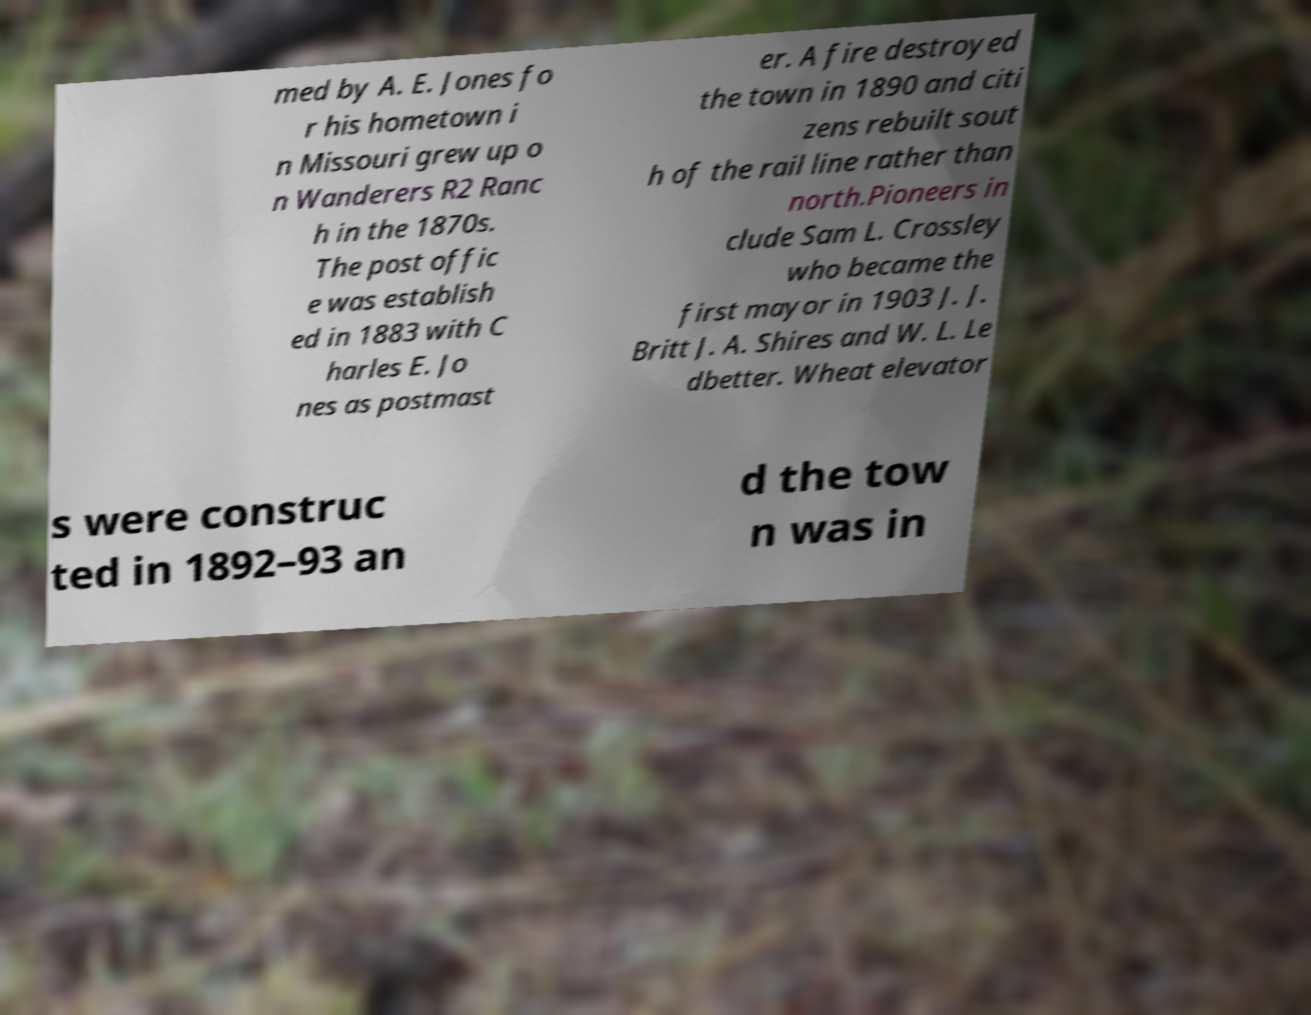There's text embedded in this image that I need extracted. Can you transcribe it verbatim? med by A. E. Jones fo r his hometown i n Missouri grew up o n Wanderers R2 Ranc h in the 1870s. The post offic e was establish ed in 1883 with C harles E. Jo nes as postmast er. A fire destroyed the town in 1890 and citi zens rebuilt sout h of the rail line rather than north.Pioneers in clude Sam L. Crossley who became the first mayor in 1903 J. J. Britt J. A. Shires and W. L. Le dbetter. Wheat elevator s were construc ted in 1892–93 an d the tow n was in 